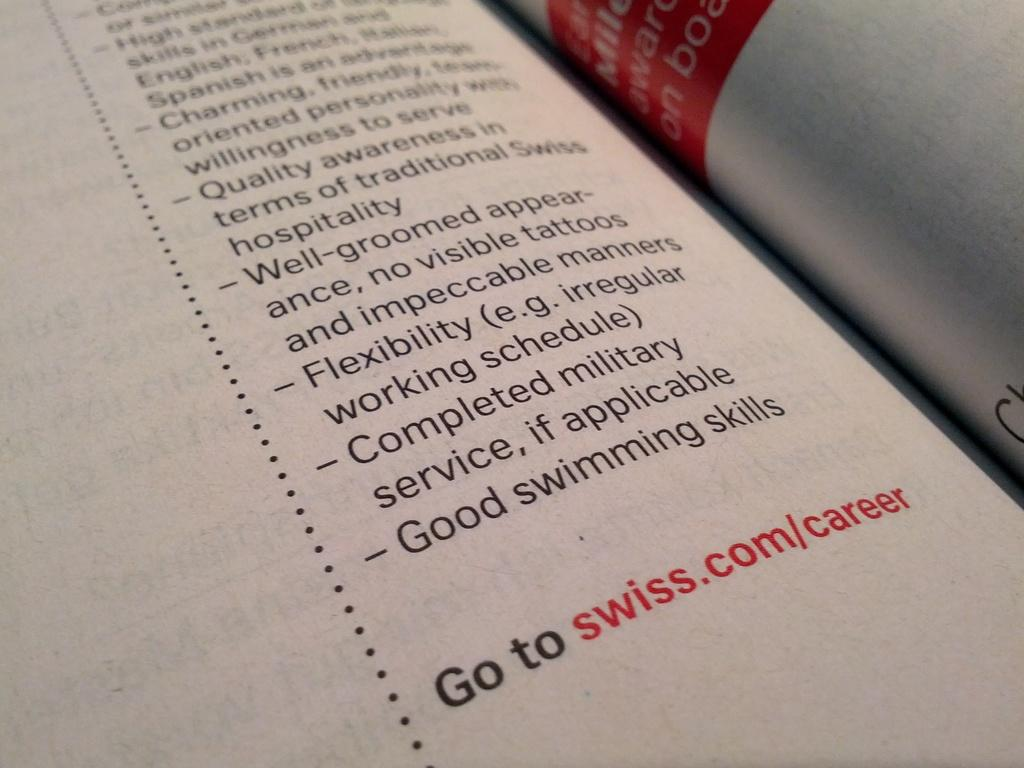<image>
Give a short and clear explanation of the subsequent image. The website swiss.com/career appears below a printed passage. 